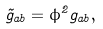Convert formula to latex. <formula><loc_0><loc_0><loc_500><loc_500>\tilde { g } _ { a b } = \phi ^ { 2 } g _ { a b } ,</formula> 